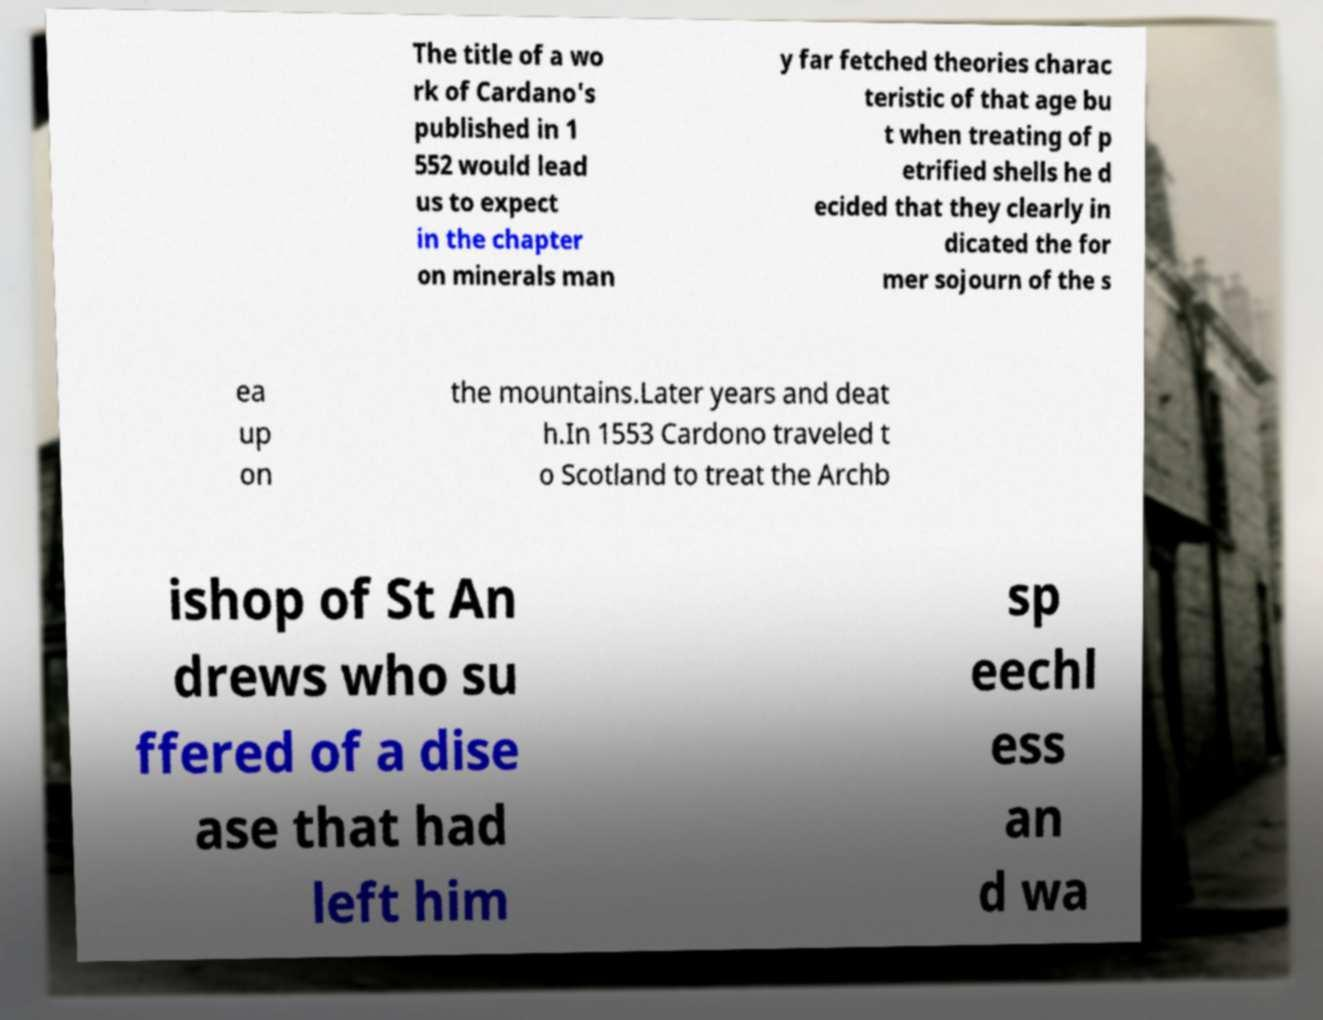Please identify and transcribe the text found in this image. The title of a wo rk of Cardano's published in 1 552 would lead us to expect in the chapter on minerals man y far fetched theories charac teristic of that age bu t when treating of p etrified shells he d ecided that they clearly in dicated the for mer sojourn of the s ea up on the mountains.Later years and deat h.In 1553 Cardono traveled t o Scotland to treat the Archb ishop of St An drews who su ffered of a dise ase that had left him sp eechl ess an d wa 